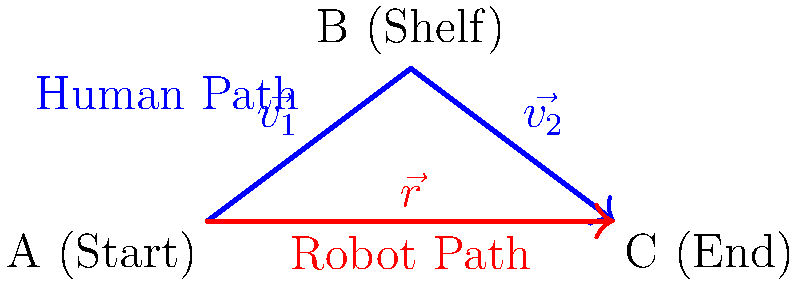In a warehouse, a human worker follows a path from point A to point B (to pick an item from a shelf) and then to point C, while a robot takes a direct path from A to C. The human's path is represented by vectors $\vec{v_1}$ and $\vec{v_2}$, while the robot's path is represented by vector $\vec{r}$. If $\vec{v_1} = 4\hat{i} + 3\hat{j}$, $\vec{v_2} = 4\hat{i} - 3\hat{j}$, and $\vec{r} = 8\hat{i}$, calculate the difference in distance traveled between the human and the robot. To solve this problem, we need to follow these steps:

1. Calculate the magnitude of the human's path:
   - The human's path is the sum of two vectors: $\vec{v_1}$ and $\vec{v_2}$
   - Magnitude of $\vec{v_1}$: $|\vec{v_1}| = \sqrt{4^2 + 3^2} = \sqrt{25} = 5$
   - Magnitude of $\vec{v_2}$: $|\vec{v_2}| = \sqrt{4^2 + (-3)^2} = \sqrt{25} = 5$
   - Total distance for human = $|\vec{v_1}| + |\vec{v_2}| = 5 + 5 = 10$ units

2. Calculate the magnitude of the robot's path:
   - The robot's path is a single vector $\vec{r} = 8\hat{i}$
   - Magnitude of $\vec{r}$: $|\vec{r}| = \sqrt{8^2} = 8$ units

3. Calculate the difference in distance:
   - Difference = Human path - Robot path
   - Difference = $10 - 8 = 2$ units

Therefore, the human travels 2 units more than the robot.
Answer: 2 units 